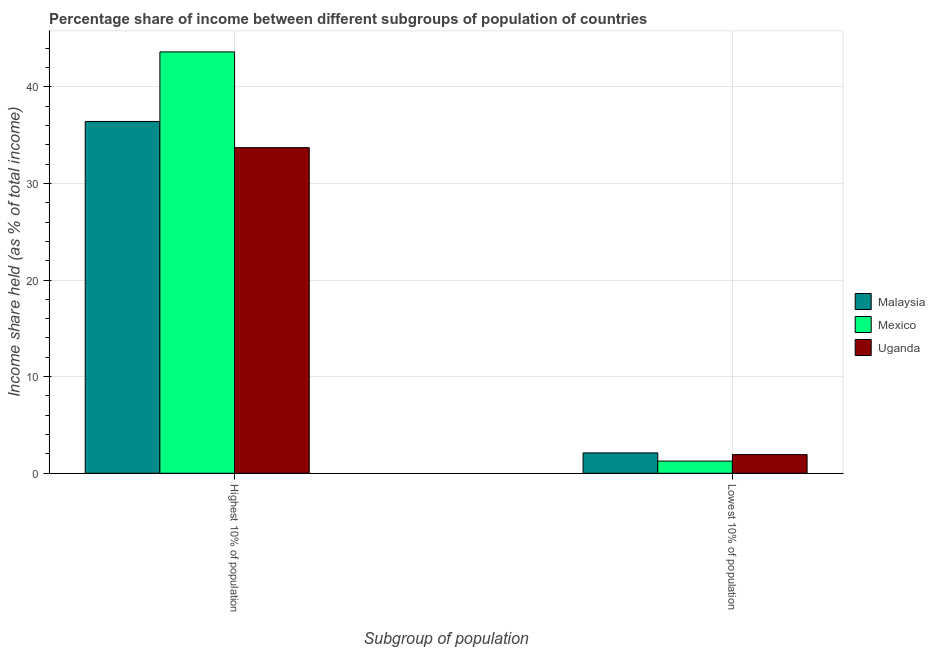How many groups of bars are there?
Provide a short and direct response. 2. How many bars are there on the 1st tick from the left?
Provide a short and direct response. 3. How many bars are there on the 1st tick from the right?
Give a very brief answer. 3. What is the label of the 2nd group of bars from the left?
Offer a very short reply. Lowest 10% of population. What is the income share held by highest 10% of the population in Uganda?
Your response must be concise. 33.7. Across all countries, what is the maximum income share held by highest 10% of the population?
Provide a succinct answer. 43.61. Across all countries, what is the minimum income share held by lowest 10% of the population?
Your answer should be very brief. 1.26. In which country was the income share held by lowest 10% of the population maximum?
Provide a succinct answer. Malaysia. In which country was the income share held by highest 10% of the population minimum?
Provide a short and direct response. Uganda. What is the total income share held by highest 10% of the population in the graph?
Your response must be concise. 113.72. What is the difference between the income share held by lowest 10% of the population in Uganda and that in Mexico?
Your answer should be compact. 0.67. What is the difference between the income share held by highest 10% of the population in Mexico and the income share held by lowest 10% of the population in Malaysia?
Your answer should be very brief. 41.5. What is the average income share held by highest 10% of the population per country?
Offer a terse response. 37.91. What is the difference between the income share held by lowest 10% of the population and income share held by highest 10% of the population in Uganda?
Your response must be concise. -31.77. What is the ratio of the income share held by highest 10% of the population in Uganda to that in Malaysia?
Offer a terse response. 0.93. What does the 3rd bar from the right in Lowest 10% of population represents?
Offer a terse response. Malaysia. How many bars are there?
Ensure brevity in your answer.  6. Are all the bars in the graph horizontal?
Provide a short and direct response. No. How many countries are there in the graph?
Offer a terse response. 3. Are the values on the major ticks of Y-axis written in scientific E-notation?
Make the answer very short. No. Does the graph contain any zero values?
Ensure brevity in your answer.  No. Does the graph contain grids?
Your response must be concise. Yes. Where does the legend appear in the graph?
Provide a short and direct response. Center right. How many legend labels are there?
Your answer should be compact. 3. How are the legend labels stacked?
Make the answer very short. Vertical. What is the title of the graph?
Make the answer very short. Percentage share of income between different subgroups of population of countries. What is the label or title of the X-axis?
Your answer should be very brief. Subgroup of population. What is the label or title of the Y-axis?
Your answer should be very brief. Income share held (as % of total income). What is the Income share held (as % of total income) in Malaysia in Highest 10% of population?
Give a very brief answer. 36.41. What is the Income share held (as % of total income) in Mexico in Highest 10% of population?
Provide a succinct answer. 43.61. What is the Income share held (as % of total income) of Uganda in Highest 10% of population?
Provide a short and direct response. 33.7. What is the Income share held (as % of total income) of Malaysia in Lowest 10% of population?
Offer a terse response. 2.11. What is the Income share held (as % of total income) in Mexico in Lowest 10% of population?
Your answer should be compact. 1.26. What is the Income share held (as % of total income) of Uganda in Lowest 10% of population?
Ensure brevity in your answer.  1.93. Across all Subgroup of population, what is the maximum Income share held (as % of total income) in Malaysia?
Make the answer very short. 36.41. Across all Subgroup of population, what is the maximum Income share held (as % of total income) in Mexico?
Ensure brevity in your answer.  43.61. Across all Subgroup of population, what is the maximum Income share held (as % of total income) in Uganda?
Make the answer very short. 33.7. Across all Subgroup of population, what is the minimum Income share held (as % of total income) of Malaysia?
Offer a very short reply. 2.11. Across all Subgroup of population, what is the minimum Income share held (as % of total income) of Mexico?
Provide a succinct answer. 1.26. Across all Subgroup of population, what is the minimum Income share held (as % of total income) of Uganda?
Your answer should be very brief. 1.93. What is the total Income share held (as % of total income) of Malaysia in the graph?
Your answer should be compact. 38.52. What is the total Income share held (as % of total income) in Mexico in the graph?
Make the answer very short. 44.87. What is the total Income share held (as % of total income) of Uganda in the graph?
Provide a short and direct response. 35.63. What is the difference between the Income share held (as % of total income) of Malaysia in Highest 10% of population and that in Lowest 10% of population?
Your answer should be compact. 34.3. What is the difference between the Income share held (as % of total income) in Mexico in Highest 10% of population and that in Lowest 10% of population?
Provide a succinct answer. 42.35. What is the difference between the Income share held (as % of total income) of Uganda in Highest 10% of population and that in Lowest 10% of population?
Provide a short and direct response. 31.77. What is the difference between the Income share held (as % of total income) in Malaysia in Highest 10% of population and the Income share held (as % of total income) in Mexico in Lowest 10% of population?
Your answer should be compact. 35.15. What is the difference between the Income share held (as % of total income) of Malaysia in Highest 10% of population and the Income share held (as % of total income) of Uganda in Lowest 10% of population?
Provide a succinct answer. 34.48. What is the difference between the Income share held (as % of total income) in Mexico in Highest 10% of population and the Income share held (as % of total income) in Uganda in Lowest 10% of population?
Ensure brevity in your answer.  41.68. What is the average Income share held (as % of total income) in Malaysia per Subgroup of population?
Your response must be concise. 19.26. What is the average Income share held (as % of total income) in Mexico per Subgroup of population?
Provide a short and direct response. 22.43. What is the average Income share held (as % of total income) in Uganda per Subgroup of population?
Offer a very short reply. 17.82. What is the difference between the Income share held (as % of total income) in Malaysia and Income share held (as % of total income) in Uganda in Highest 10% of population?
Offer a terse response. 2.71. What is the difference between the Income share held (as % of total income) in Mexico and Income share held (as % of total income) in Uganda in Highest 10% of population?
Keep it short and to the point. 9.91. What is the difference between the Income share held (as % of total income) of Malaysia and Income share held (as % of total income) of Uganda in Lowest 10% of population?
Your answer should be very brief. 0.18. What is the difference between the Income share held (as % of total income) of Mexico and Income share held (as % of total income) of Uganda in Lowest 10% of population?
Give a very brief answer. -0.67. What is the ratio of the Income share held (as % of total income) in Malaysia in Highest 10% of population to that in Lowest 10% of population?
Make the answer very short. 17.26. What is the ratio of the Income share held (as % of total income) of Mexico in Highest 10% of population to that in Lowest 10% of population?
Your response must be concise. 34.61. What is the ratio of the Income share held (as % of total income) of Uganda in Highest 10% of population to that in Lowest 10% of population?
Your response must be concise. 17.46. What is the difference between the highest and the second highest Income share held (as % of total income) of Malaysia?
Your answer should be very brief. 34.3. What is the difference between the highest and the second highest Income share held (as % of total income) of Mexico?
Your answer should be compact. 42.35. What is the difference between the highest and the second highest Income share held (as % of total income) in Uganda?
Give a very brief answer. 31.77. What is the difference between the highest and the lowest Income share held (as % of total income) of Malaysia?
Provide a short and direct response. 34.3. What is the difference between the highest and the lowest Income share held (as % of total income) in Mexico?
Provide a short and direct response. 42.35. What is the difference between the highest and the lowest Income share held (as % of total income) of Uganda?
Your answer should be compact. 31.77. 